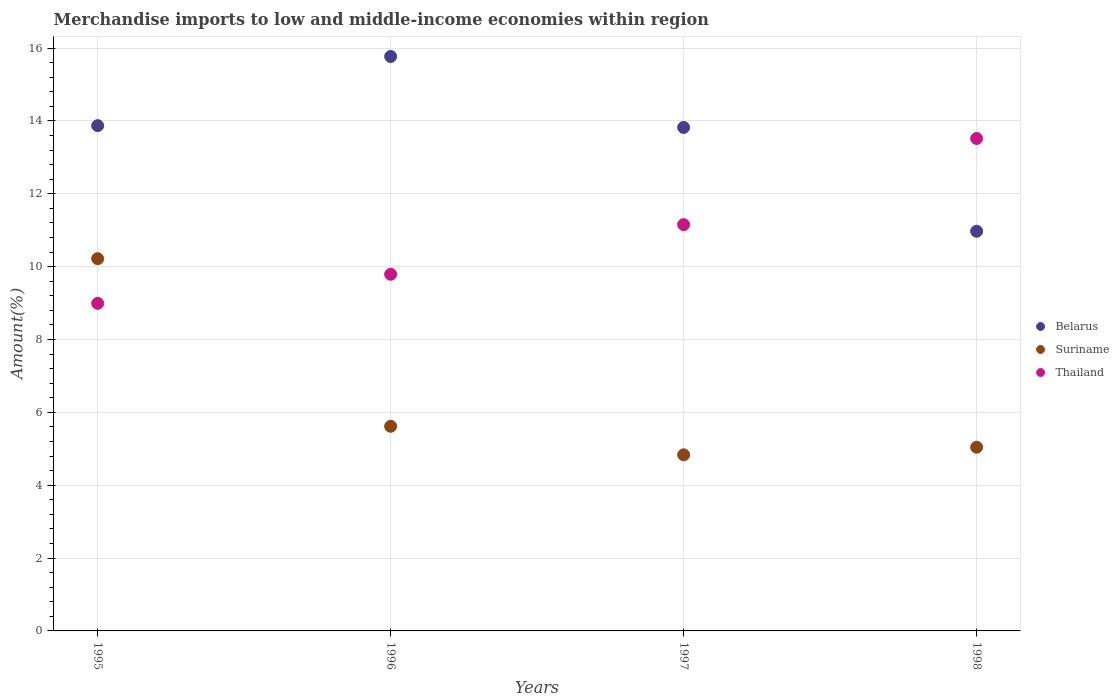What is the percentage of amount earned from merchandise imports in Thailand in 1995?
Your answer should be very brief. 8.99. Across all years, what is the maximum percentage of amount earned from merchandise imports in Belarus?
Offer a very short reply. 15.77. Across all years, what is the minimum percentage of amount earned from merchandise imports in Belarus?
Your answer should be very brief. 10.97. In which year was the percentage of amount earned from merchandise imports in Suriname minimum?
Offer a terse response. 1997. What is the total percentage of amount earned from merchandise imports in Belarus in the graph?
Provide a succinct answer. 54.44. What is the difference between the percentage of amount earned from merchandise imports in Suriname in 1997 and that in 1998?
Make the answer very short. -0.21. What is the difference between the percentage of amount earned from merchandise imports in Thailand in 1995 and the percentage of amount earned from merchandise imports in Belarus in 1996?
Give a very brief answer. -6.78. What is the average percentage of amount earned from merchandise imports in Suriname per year?
Your response must be concise. 6.43. In the year 1995, what is the difference between the percentage of amount earned from merchandise imports in Suriname and percentage of amount earned from merchandise imports in Belarus?
Your response must be concise. -3.65. What is the ratio of the percentage of amount earned from merchandise imports in Belarus in 1996 to that in 1998?
Ensure brevity in your answer.  1.44. Is the percentage of amount earned from merchandise imports in Belarus in 1995 less than that in 1996?
Provide a short and direct response. Yes. Is the difference between the percentage of amount earned from merchandise imports in Suriname in 1995 and 1998 greater than the difference between the percentage of amount earned from merchandise imports in Belarus in 1995 and 1998?
Provide a short and direct response. Yes. What is the difference between the highest and the second highest percentage of amount earned from merchandise imports in Thailand?
Ensure brevity in your answer.  2.37. What is the difference between the highest and the lowest percentage of amount earned from merchandise imports in Suriname?
Ensure brevity in your answer.  5.38. Is it the case that in every year, the sum of the percentage of amount earned from merchandise imports in Thailand and percentage of amount earned from merchandise imports in Suriname  is greater than the percentage of amount earned from merchandise imports in Belarus?
Your answer should be very brief. No. Does the percentage of amount earned from merchandise imports in Belarus monotonically increase over the years?
Offer a very short reply. No. Is the percentage of amount earned from merchandise imports in Belarus strictly less than the percentage of amount earned from merchandise imports in Thailand over the years?
Your response must be concise. No. How many years are there in the graph?
Ensure brevity in your answer.  4. What is the difference between two consecutive major ticks on the Y-axis?
Give a very brief answer. 2. Does the graph contain any zero values?
Your answer should be very brief. No. How many legend labels are there?
Ensure brevity in your answer.  3. What is the title of the graph?
Make the answer very short. Merchandise imports to low and middle-income economies within region. What is the label or title of the Y-axis?
Keep it short and to the point. Amount(%). What is the Amount(%) of Belarus in 1995?
Your answer should be compact. 13.87. What is the Amount(%) of Suriname in 1995?
Your answer should be compact. 10.22. What is the Amount(%) in Thailand in 1995?
Give a very brief answer. 8.99. What is the Amount(%) of Belarus in 1996?
Give a very brief answer. 15.77. What is the Amount(%) in Suriname in 1996?
Provide a succinct answer. 5.62. What is the Amount(%) in Thailand in 1996?
Ensure brevity in your answer.  9.79. What is the Amount(%) in Belarus in 1997?
Offer a very short reply. 13.82. What is the Amount(%) of Suriname in 1997?
Ensure brevity in your answer.  4.83. What is the Amount(%) of Thailand in 1997?
Your answer should be very brief. 11.15. What is the Amount(%) in Belarus in 1998?
Offer a very short reply. 10.97. What is the Amount(%) in Suriname in 1998?
Give a very brief answer. 5.04. What is the Amount(%) of Thailand in 1998?
Your answer should be very brief. 13.52. Across all years, what is the maximum Amount(%) of Belarus?
Provide a short and direct response. 15.77. Across all years, what is the maximum Amount(%) in Suriname?
Your response must be concise. 10.22. Across all years, what is the maximum Amount(%) in Thailand?
Provide a short and direct response. 13.52. Across all years, what is the minimum Amount(%) of Belarus?
Your response must be concise. 10.97. Across all years, what is the minimum Amount(%) of Suriname?
Offer a terse response. 4.83. Across all years, what is the minimum Amount(%) of Thailand?
Your response must be concise. 8.99. What is the total Amount(%) of Belarus in the graph?
Your answer should be very brief. 54.44. What is the total Amount(%) of Suriname in the graph?
Keep it short and to the point. 25.72. What is the total Amount(%) of Thailand in the graph?
Ensure brevity in your answer.  43.46. What is the difference between the Amount(%) of Belarus in 1995 and that in 1996?
Provide a short and direct response. -1.9. What is the difference between the Amount(%) in Suriname in 1995 and that in 1996?
Your response must be concise. 4.6. What is the difference between the Amount(%) in Thailand in 1995 and that in 1996?
Give a very brief answer. -0.8. What is the difference between the Amount(%) of Belarus in 1995 and that in 1997?
Ensure brevity in your answer.  0.05. What is the difference between the Amount(%) in Suriname in 1995 and that in 1997?
Offer a terse response. 5.38. What is the difference between the Amount(%) in Thailand in 1995 and that in 1997?
Make the answer very short. -2.16. What is the difference between the Amount(%) in Belarus in 1995 and that in 1998?
Keep it short and to the point. 2.9. What is the difference between the Amount(%) in Suriname in 1995 and that in 1998?
Provide a succinct answer. 5.18. What is the difference between the Amount(%) of Thailand in 1995 and that in 1998?
Provide a short and direct response. -4.53. What is the difference between the Amount(%) in Belarus in 1996 and that in 1997?
Give a very brief answer. 1.95. What is the difference between the Amount(%) in Suriname in 1996 and that in 1997?
Make the answer very short. 0.78. What is the difference between the Amount(%) in Thailand in 1996 and that in 1997?
Ensure brevity in your answer.  -1.36. What is the difference between the Amount(%) in Belarus in 1996 and that in 1998?
Ensure brevity in your answer.  4.8. What is the difference between the Amount(%) in Suriname in 1996 and that in 1998?
Make the answer very short. 0.58. What is the difference between the Amount(%) of Thailand in 1996 and that in 1998?
Make the answer very short. -3.73. What is the difference between the Amount(%) in Belarus in 1997 and that in 1998?
Provide a succinct answer. 2.85. What is the difference between the Amount(%) in Suriname in 1997 and that in 1998?
Your answer should be very brief. -0.21. What is the difference between the Amount(%) of Thailand in 1997 and that in 1998?
Give a very brief answer. -2.37. What is the difference between the Amount(%) in Belarus in 1995 and the Amount(%) in Suriname in 1996?
Make the answer very short. 8.25. What is the difference between the Amount(%) in Belarus in 1995 and the Amount(%) in Thailand in 1996?
Offer a terse response. 4.08. What is the difference between the Amount(%) in Suriname in 1995 and the Amount(%) in Thailand in 1996?
Keep it short and to the point. 0.43. What is the difference between the Amount(%) in Belarus in 1995 and the Amount(%) in Suriname in 1997?
Your answer should be very brief. 9.04. What is the difference between the Amount(%) in Belarus in 1995 and the Amount(%) in Thailand in 1997?
Give a very brief answer. 2.72. What is the difference between the Amount(%) of Suriname in 1995 and the Amount(%) of Thailand in 1997?
Offer a very short reply. -0.93. What is the difference between the Amount(%) in Belarus in 1995 and the Amount(%) in Suriname in 1998?
Offer a terse response. 8.83. What is the difference between the Amount(%) of Belarus in 1995 and the Amount(%) of Thailand in 1998?
Offer a very short reply. 0.35. What is the difference between the Amount(%) in Suriname in 1995 and the Amount(%) in Thailand in 1998?
Keep it short and to the point. -3.3. What is the difference between the Amount(%) of Belarus in 1996 and the Amount(%) of Suriname in 1997?
Provide a succinct answer. 10.94. What is the difference between the Amount(%) in Belarus in 1996 and the Amount(%) in Thailand in 1997?
Provide a succinct answer. 4.62. What is the difference between the Amount(%) in Suriname in 1996 and the Amount(%) in Thailand in 1997?
Your answer should be compact. -5.54. What is the difference between the Amount(%) in Belarus in 1996 and the Amount(%) in Suriname in 1998?
Your answer should be compact. 10.73. What is the difference between the Amount(%) of Belarus in 1996 and the Amount(%) of Thailand in 1998?
Offer a terse response. 2.25. What is the difference between the Amount(%) in Suriname in 1996 and the Amount(%) in Thailand in 1998?
Your response must be concise. -7.9. What is the difference between the Amount(%) of Belarus in 1997 and the Amount(%) of Suriname in 1998?
Keep it short and to the point. 8.78. What is the difference between the Amount(%) in Belarus in 1997 and the Amount(%) in Thailand in 1998?
Make the answer very short. 0.3. What is the difference between the Amount(%) in Suriname in 1997 and the Amount(%) in Thailand in 1998?
Keep it short and to the point. -8.68. What is the average Amount(%) in Belarus per year?
Your answer should be very brief. 13.61. What is the average Amount(%) of Suriname per year?
Provide a short and direct response. 6.43. What is the average Amount(%) of Thailand per year?
Ensure brevity in your answer.  10.86. In the year 1995, what is the difference between the Amount(%) in Belarus and Amount(%) in Suriname?
Give a very brief answer. 3.65. In the year 1995, what is the difference between the Amount(%) in Belarus and Amount(%) in Thailand?
Offer a very short reply. 4.88. In the year 1995, what is the difference between the Amount(%) of Suriname and Amount(%) of Thailand?
Offer a very short reply. 1.23. In the year 1996, what is the difference between the Amount(%) of Belarus and Amount(%) of Suriname?
Make the answer very short. 10.15. In the year 1996, what is the difference between the Amount(%) in Belarus and Amount(%) in Thailand?
Your response must be concise. 5.98. In the year 1996, what is the difference between the Amount(%) in Suriname and Amount(%) in Thailand?
Your response must be concise. -4.17. In the year 1997, what is the difference between the Amount(%) in Belarus and Amount(%) in Suriname?
Give a very brief answer. 8.99. In the year 1997, what is the difference between the Amount(%) of Belarus and Amount(%) of Thailand?
Offer a terse response. 2.67. In the year 1997, what is the difference between the Amount(%) of Suriname and Amount(%) of Thailand?
Offer a very short reply. -6.32. In the year 1998, what is the difference between the Amount(%) of Belarus and Amount(%) of Suriname?
Offer a very short reply. 5.93. In the year 1998, what is the difference between the Amount(%) of Belarus and Amount(%) of Thailand?
Provide a short and direct response. -2.55. In the year 1998, what is the difference between the Amount(%) of Suriname and Amount(%) of Thailand?
Your response must be concise. -8.48. What is the ratio of the Amount(%) in Belarus in 1995 to that in 1996?
Provide a short and direct response. 0.88. What is the ratio of the Amount(%) in Suriname in 1995 to that in 1996?
Keep it short and to the point. 1.82. What is the ratio of the Amount(%) of Thailand in 1995 to that in 1996?
Your response must be concise. 0.92. What is the ratio of the Amount(%) in Suriname in 1995 to that in 1997?
Provide a succinct answer. 2.11. What is the ratio of the Amount(%) in Thailand in 1995 to that in 1997?
Your response must be concise. 0.81. What is the ratio of the Amount(%) of Belarus in 1995 to that in 1998?
Your response must be concise. 1.26. What is the ratio of the Amount(%) of Suriname in 1995 to that in 1998?
Keep it short and to the point. 2.03. What is the ratio of the Amount(%) of Thailand in 1995 to that in 1998?
Ensure brevity in your answer.  0.67. What is the ratio of the Amount(%) in Belarus in 1996 to that in 1997?
Provide a short and direct response. 1.14. What is the ratio of the Amount(%) of Suriname in 1996 to that in 1997?
Make the answer very short. 1.16. What is the ratio of the Amount(%) of Thailand in 1996 to that in 1997?
Your answer should be very brief. 0.88. What is the ratio of the Amount(%) of Belarus in 1996 to that in 1998?
Provide a short and direct response. 1.44. What is the ratio of the Amount(%) in Suriname in 1996 to that in 1998?
Offer a terse response. 1.11. What is the ratio of the Amount(%) in Thailand in 1996 to that in 1998?
Your response must be concise. 0.72. What is the ratio of the Amount(%) of Belarus in 1997 to that in 1998?
Offer a very short reply. 1.26. What is the ratio of the Amount(%) of Suriname in 1997 to that in 1998?
Your answer should be compact. 0.96. What is the ratio of the Amount(%) in Thailand in 1997 to that in 1998?
Keep it short and to the point. 0.82. What is the difference between the highest and the second highest Amount(%) in Belarus?
Make the answer very short. 1.9. What is the difference between the highest and the second highest Amount(%) of Suriname?
Give a very brief answer. 4.6. What is the difference between the highest and the second highest Amount(%) in Thailand?
Give a very brief answer. 2.37. What is the difference between the highest and the lowest Amount(%) of Belarus?
Ensure brevity in your answer.  4.8. What is the difference between the highest and the lowest Amount(%) in Suriname?
Provide a succinct answer. 5.38. What is the difference between the highest and the lowest Amount(%) of Thailand?
Keep it short and to the point. 4.53. 